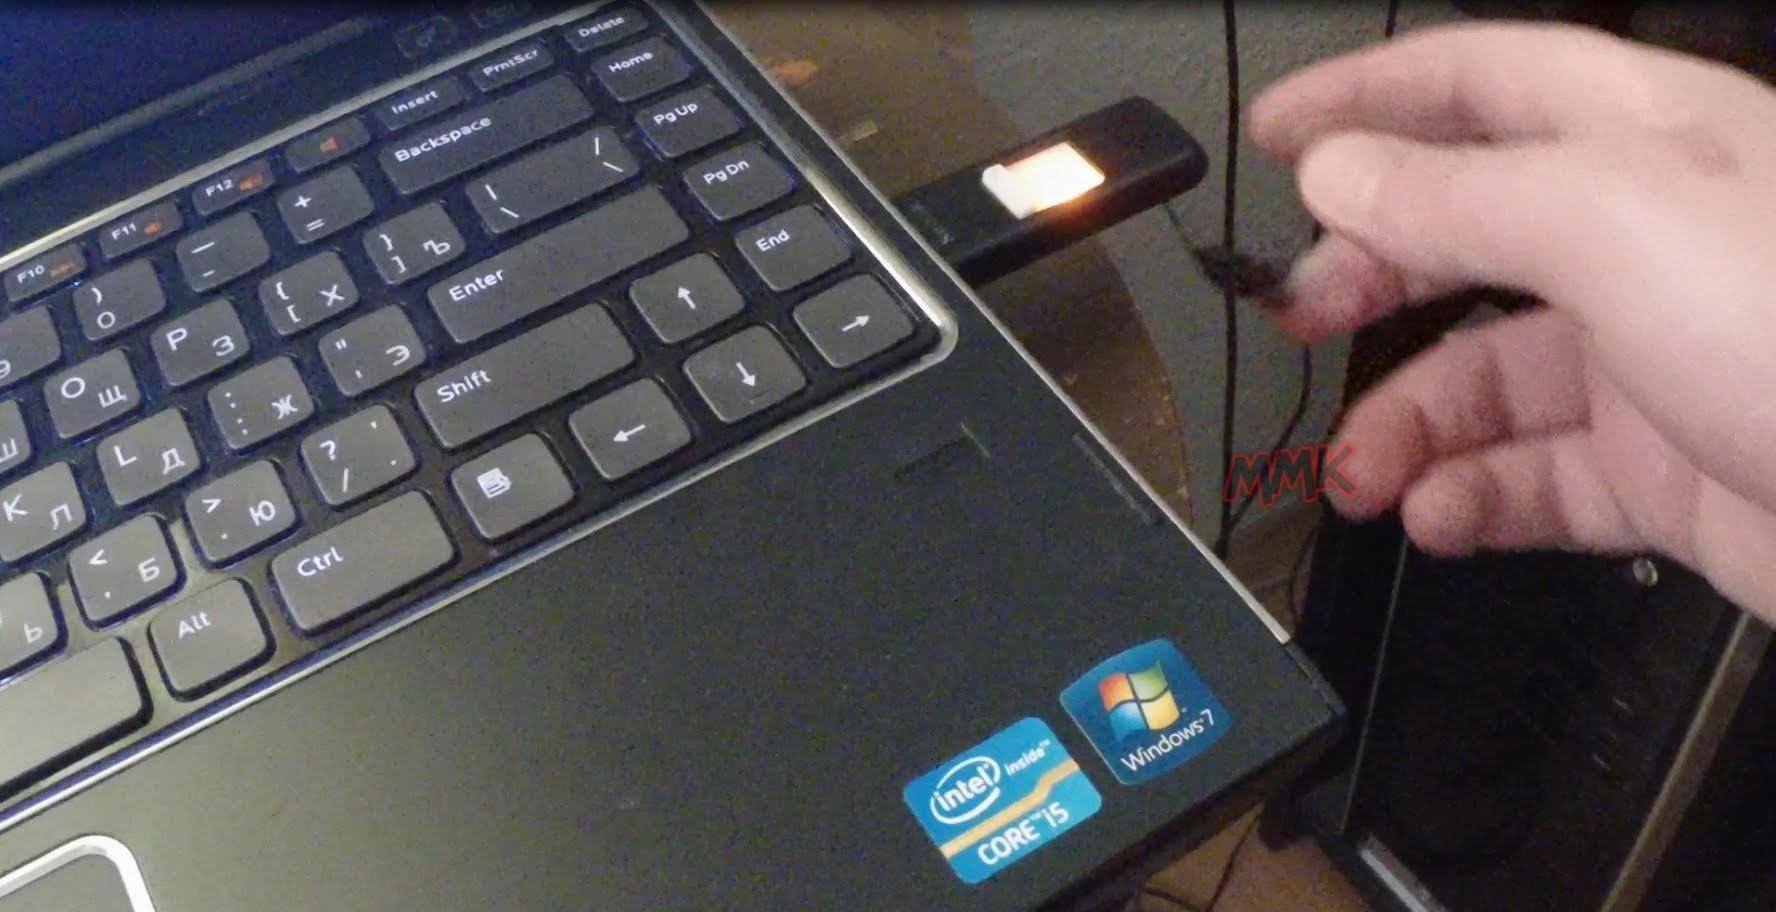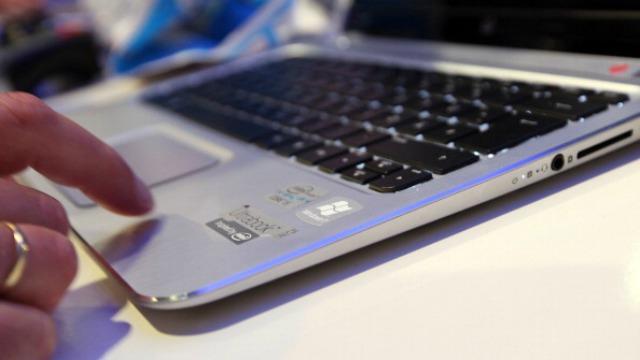The first image is the image on the left, the second image is the image on the right. For the images displayed, is the sentence "In at least one image there is a black laptop that is open and turned right." factually correct? Answer yes or no. No. The first image is the image on the left, the second image is the image on the right. Considering the images on both sides, is "One image shows a hand reaching for something plugged into the side of an open laptop." valid? Answer yes or no. Yes. 